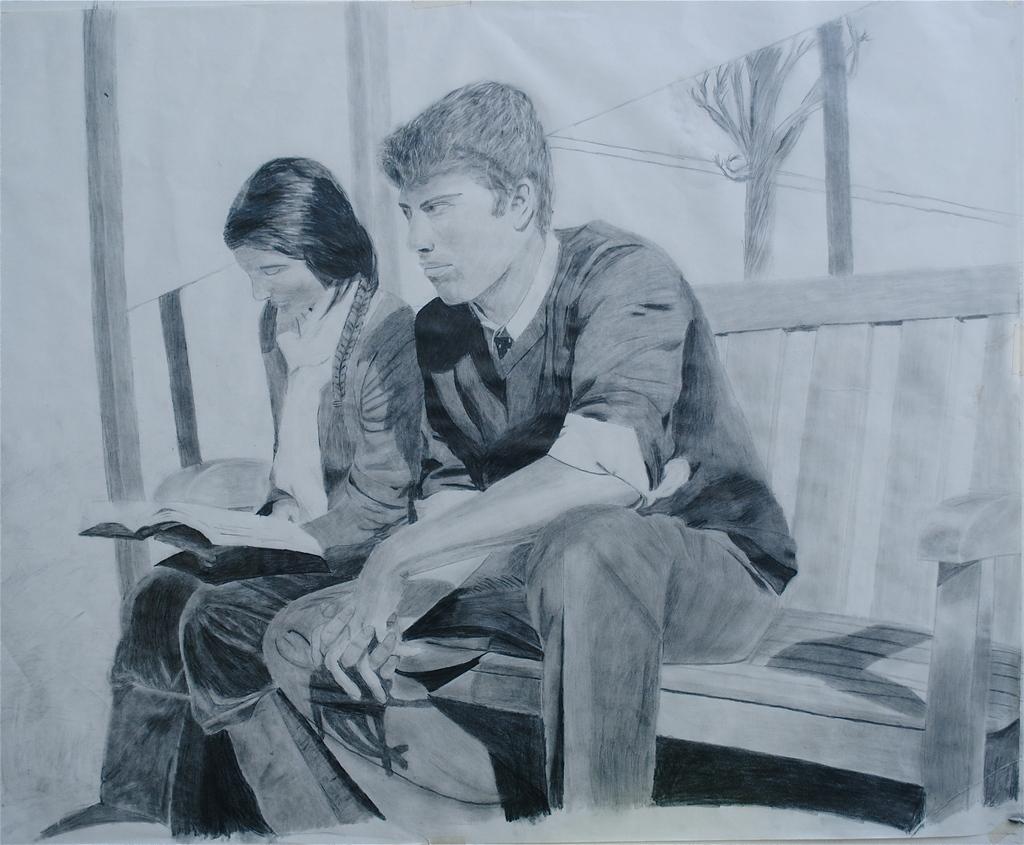Could you give a brief overview of what you see in this image? This image is a sketch. In the middle of the image a man and a woman are sitting on the bench. A woman is reading a book. This sketch is done on the paper with a pencil. 